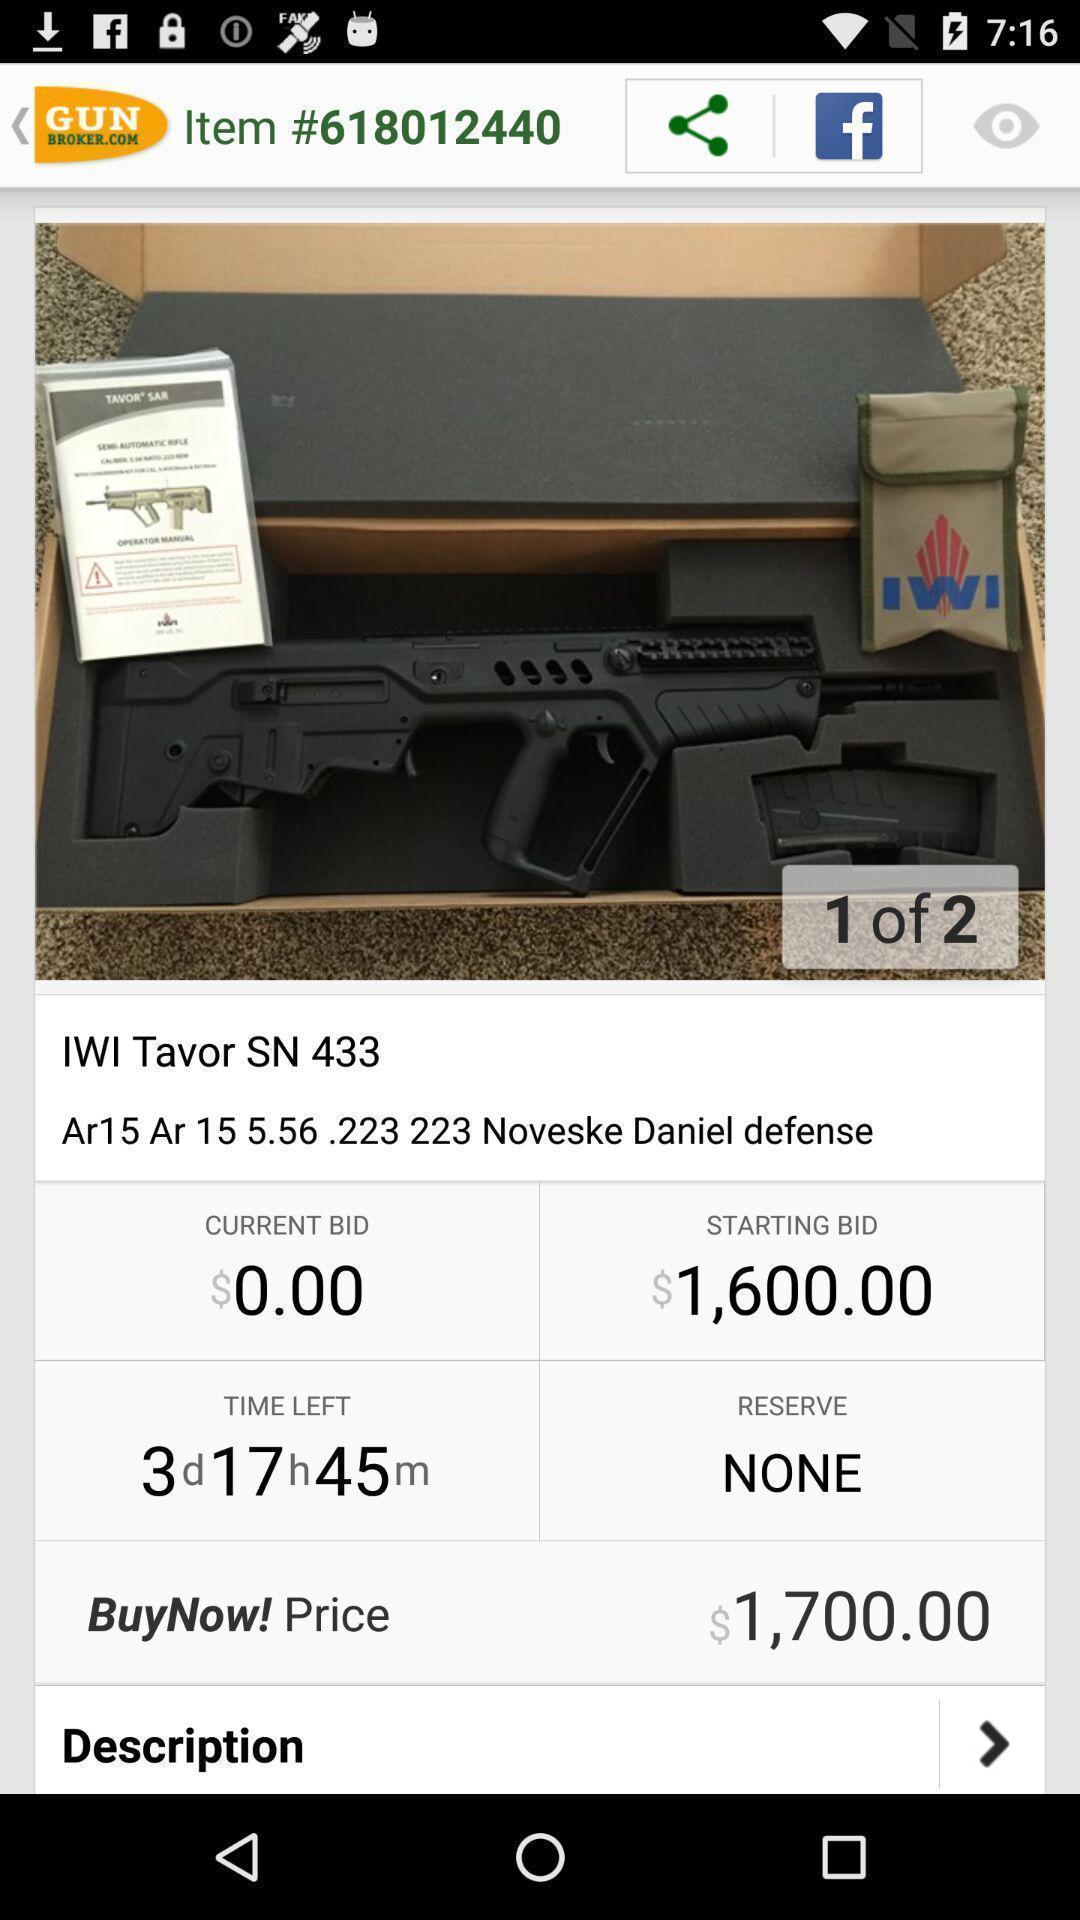Describe the content in this image. Page that displaying shopping application. 